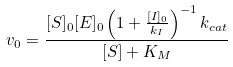<formula> <loc_0><loc_0><loc_500><loc_500>v _ { 0 } = \frac { [ S ] _ { 0 } [ E ] _ { 0 } \left ( 1 + \frac { [ I ] _ { 0 } } { k _ { I } } \right ) ^ { - 1 } k _ { c a t } } { [ S ] + K _ { M } }</formula> 